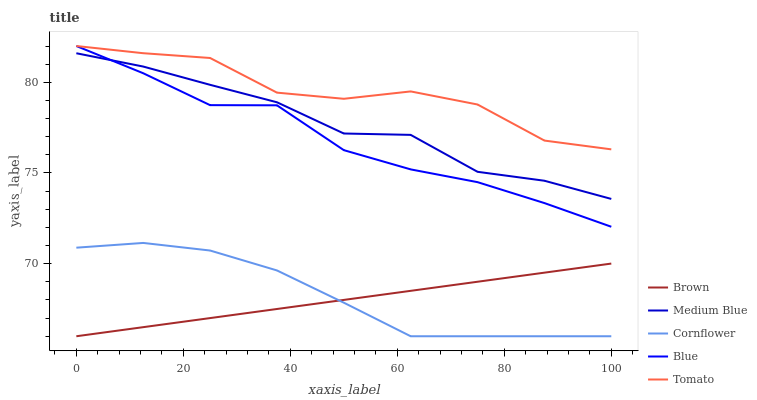Does Brown have the minimum area under the curve?
Answer yes or no. Yes. Does Tomato have the maximum area under the curve?
Answer yes or no. Yes. Does Tomato have the minimum area under the curve?
Answer yes or no. No. Does Brown have the maximum area under the curve?
Answer yes or no. No. Is Brown the smoothest?
Answer yes or no. Yes. Is Tomato the roughest?
Answer yes or no. Yes. Is Tomato the smoothest?
Answer yes or no. No. Is Brown the roughest?
Answer yes or no. No. Does Brown have the lowest value?
Answer yes or no. Yes. Does Tomato have the lowest value?
Answer yes or no. No. Does Tomato have the highest value?
Answer yes or no. Yes. Does Brown have the highest value?
Answer yes or no. No. Is Medium Blue less than Tomato?
Answer yes or no. Yes. Is Medium Blue greater than Cornflower?
Answer yes or no. Yes. Does Medium Blue intersect Blue?
Answer yes or no. Yes. Is Medium Blue less than Blue?
Answer yes or no. No. Is Medium Blue greater than Blue?
Answer yes or no. No. Does Medium Blue intersect Tomato?
Answer yes or no. No. 